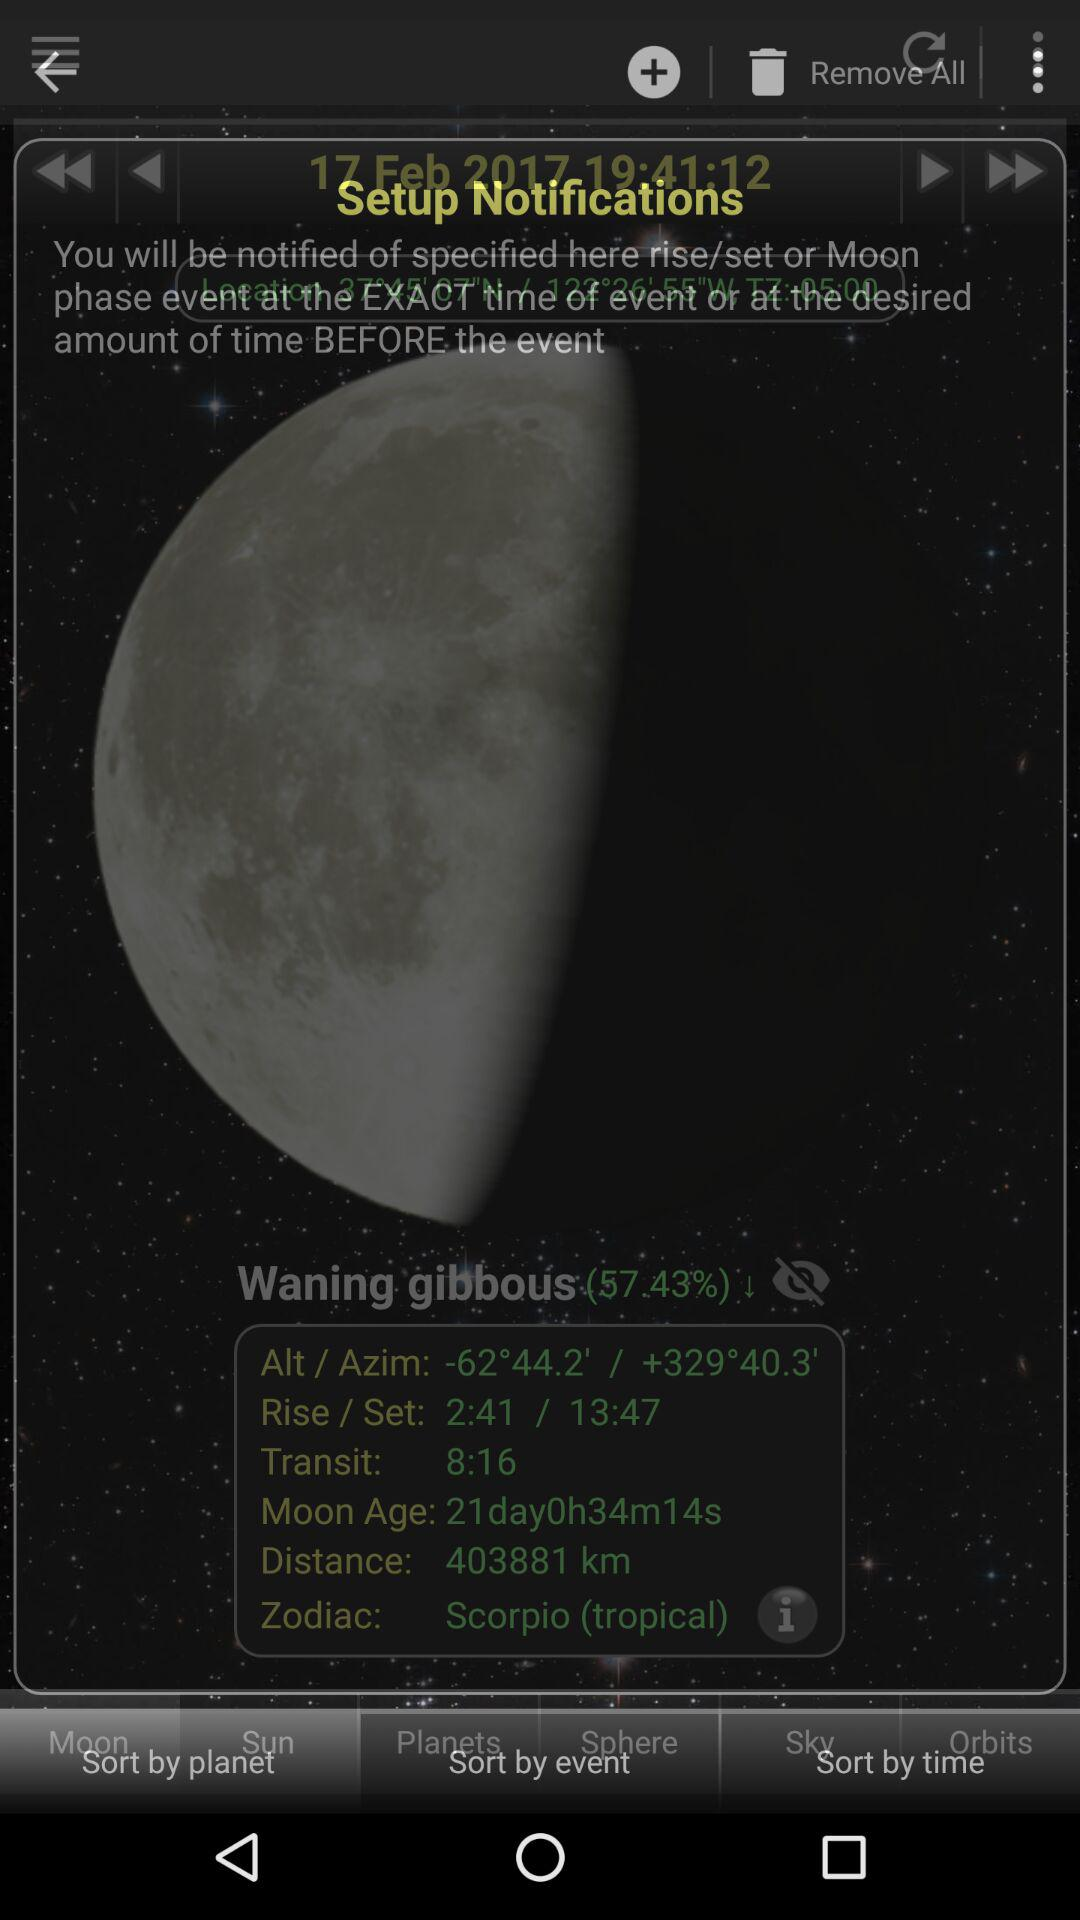What is the age of the moon? The age of the moon is 21 days, 0 hours, 34 minutes, and 14 seconds. 